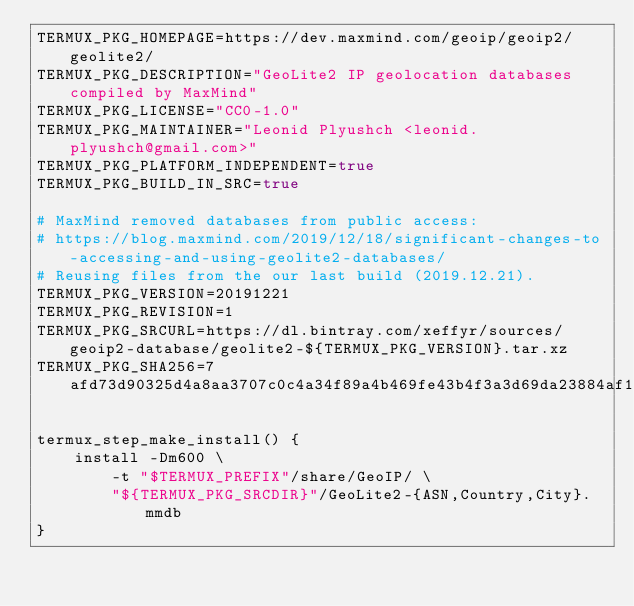Convert code to text. <code><loc_0><loc_0><loc_500><loc_500><_Bash_>TERMUX_PKG_HOMEPAGE=https://dev.maxmind.com/geoip/geoip2/geolite2/
TERMUX_PKG_DESCRIPTION="GeoLite2 IP geolocation databases compiled by MaxMind"
TERMUX_PKG_LICENSE="CC0-1.0"
TERMUX_PKG_MAINTAINER="Leonid Plyushch <leonid.plyushch@gmail.com>"
TERMUX_PKG_PLATFORM_INDEPENDENT=true
TERMUX_PKG_BUILD_IN_SRC=true

# MaxMind removed databases from public access:
# https://blog.maxmind.com/2019/12/18/significant-changes-to-accessing-and-using-geolite2-databases/
# Reusing files from the our last build (2019.12.21).
TERMUX_PKG_VERSION=20191221
TERMUX_PKG_REVISION=1
TERMUX_PKG_SRCURL=https://dl.bintray.com/xeffyr/sources/geoip2-database/geolite2-${TERMUX_PKG_VERSION}.tar.xz
TERMUX_PKG_SHA256=7afd73d90325d4a8aa3707c0c4a34f89a4b469fe43b4f3a3d69da23884af1e70

termux_step_make_install() {
	install -Dm600 \
		-t "$TERMUX_PREFIX"/share/GeoIP/ \
		"${TERMUX_PKG_SRCDIR}"/GeoLite2-{ASN,Country,City}.mmdb
}
</code> 